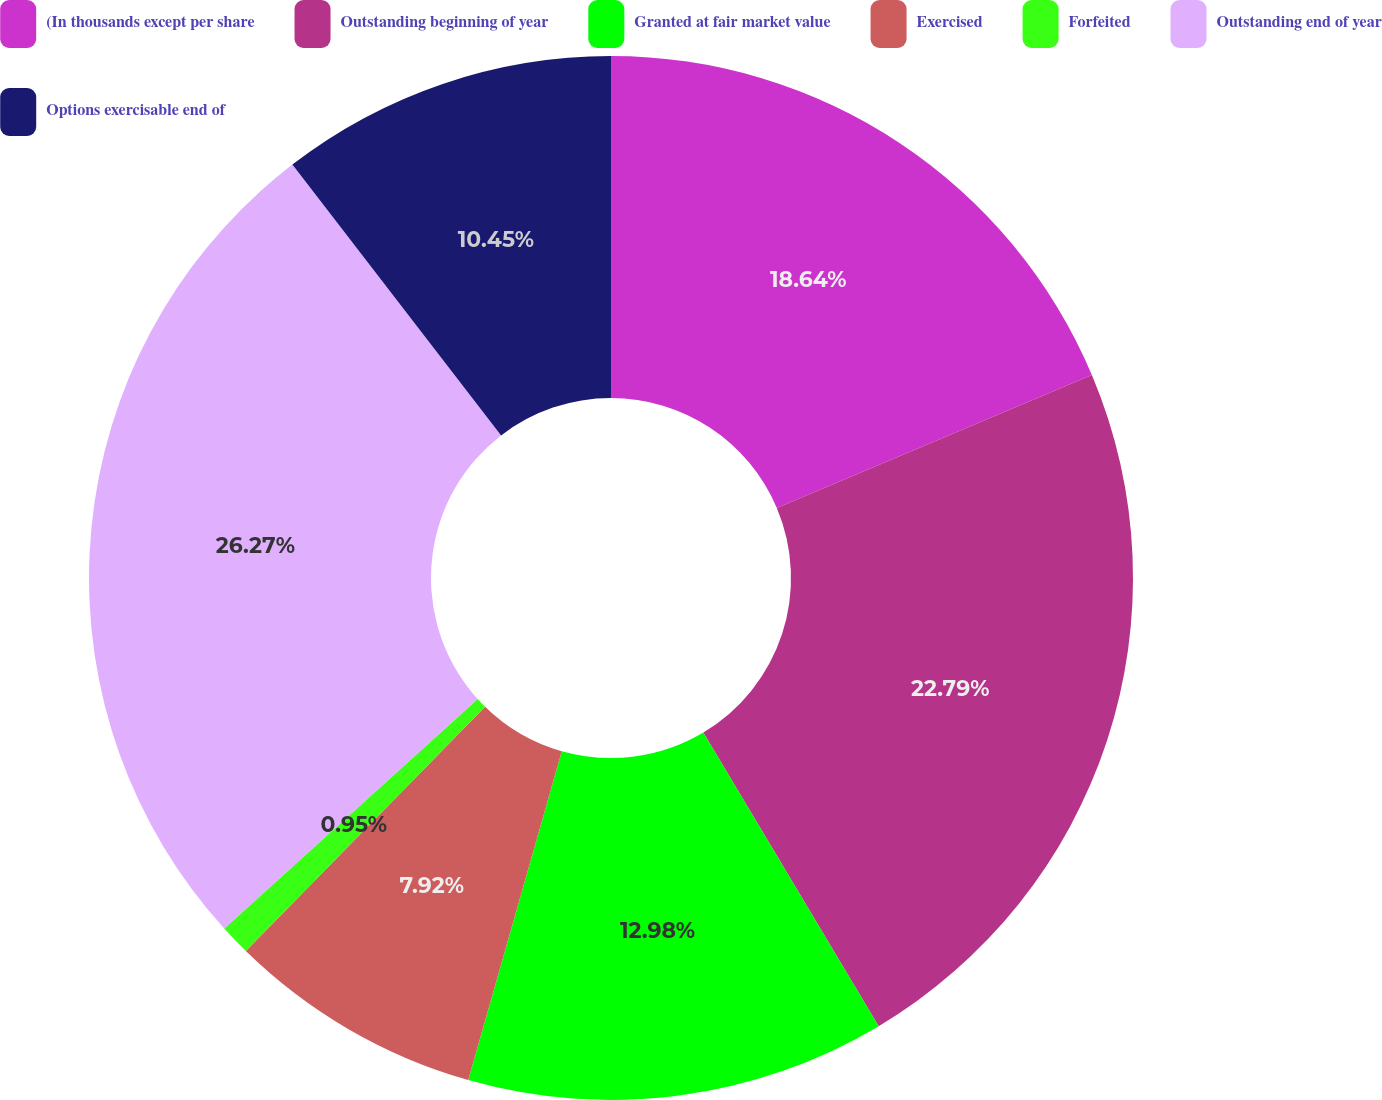Convert chart. <chart><loc_0><loc_0><loc_500><loc_500><pie_chart><fcel>(In thousands except per share<fcel>Outstanding beginning of year<fcel>Granted at fair market value<fcel>Exercised<fcel>Forfeited<fcel>Outstanding end of year<fcel>Options exercisable end of<nl><fcel>18.64%<fcel>22.79%<fcel>12.98%<fcel>7.92%<fcel>0.95%<fcel>26.27%<fcel>10.45%<nl></chart> 